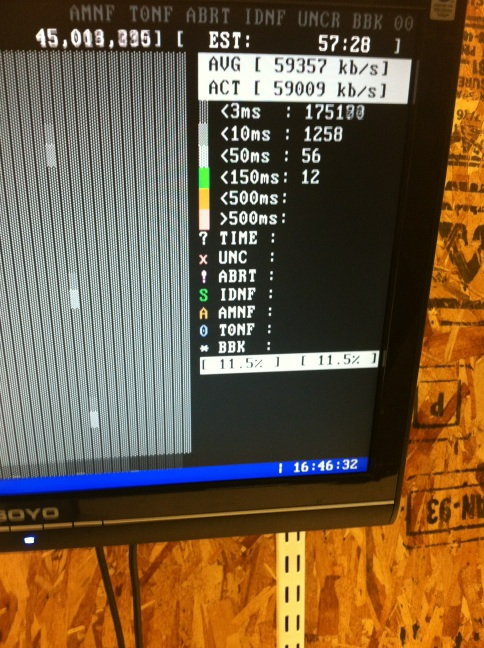Does the screen say? The screen displays various data related to network or data transmission speeds and statistics such as 'AVG', 'ACT', and 'EST' with corresponding values, along with a session time at the bottom. 